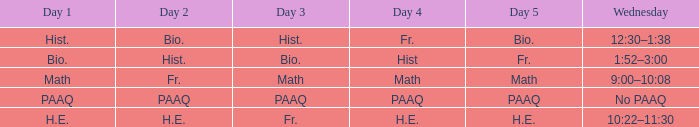What is the day 3 when day 4 is fr.? Hist. 